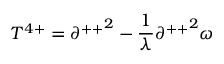<formula> <loc_0><loc_0><loc_500><loc_500>T ^ { 4 + } = { \partial ^ { + + } } ^ { 2 } - \frac { 1 } { \lambda } { \partial ^ { + + } } ^ { 2 } \omega</formula> 